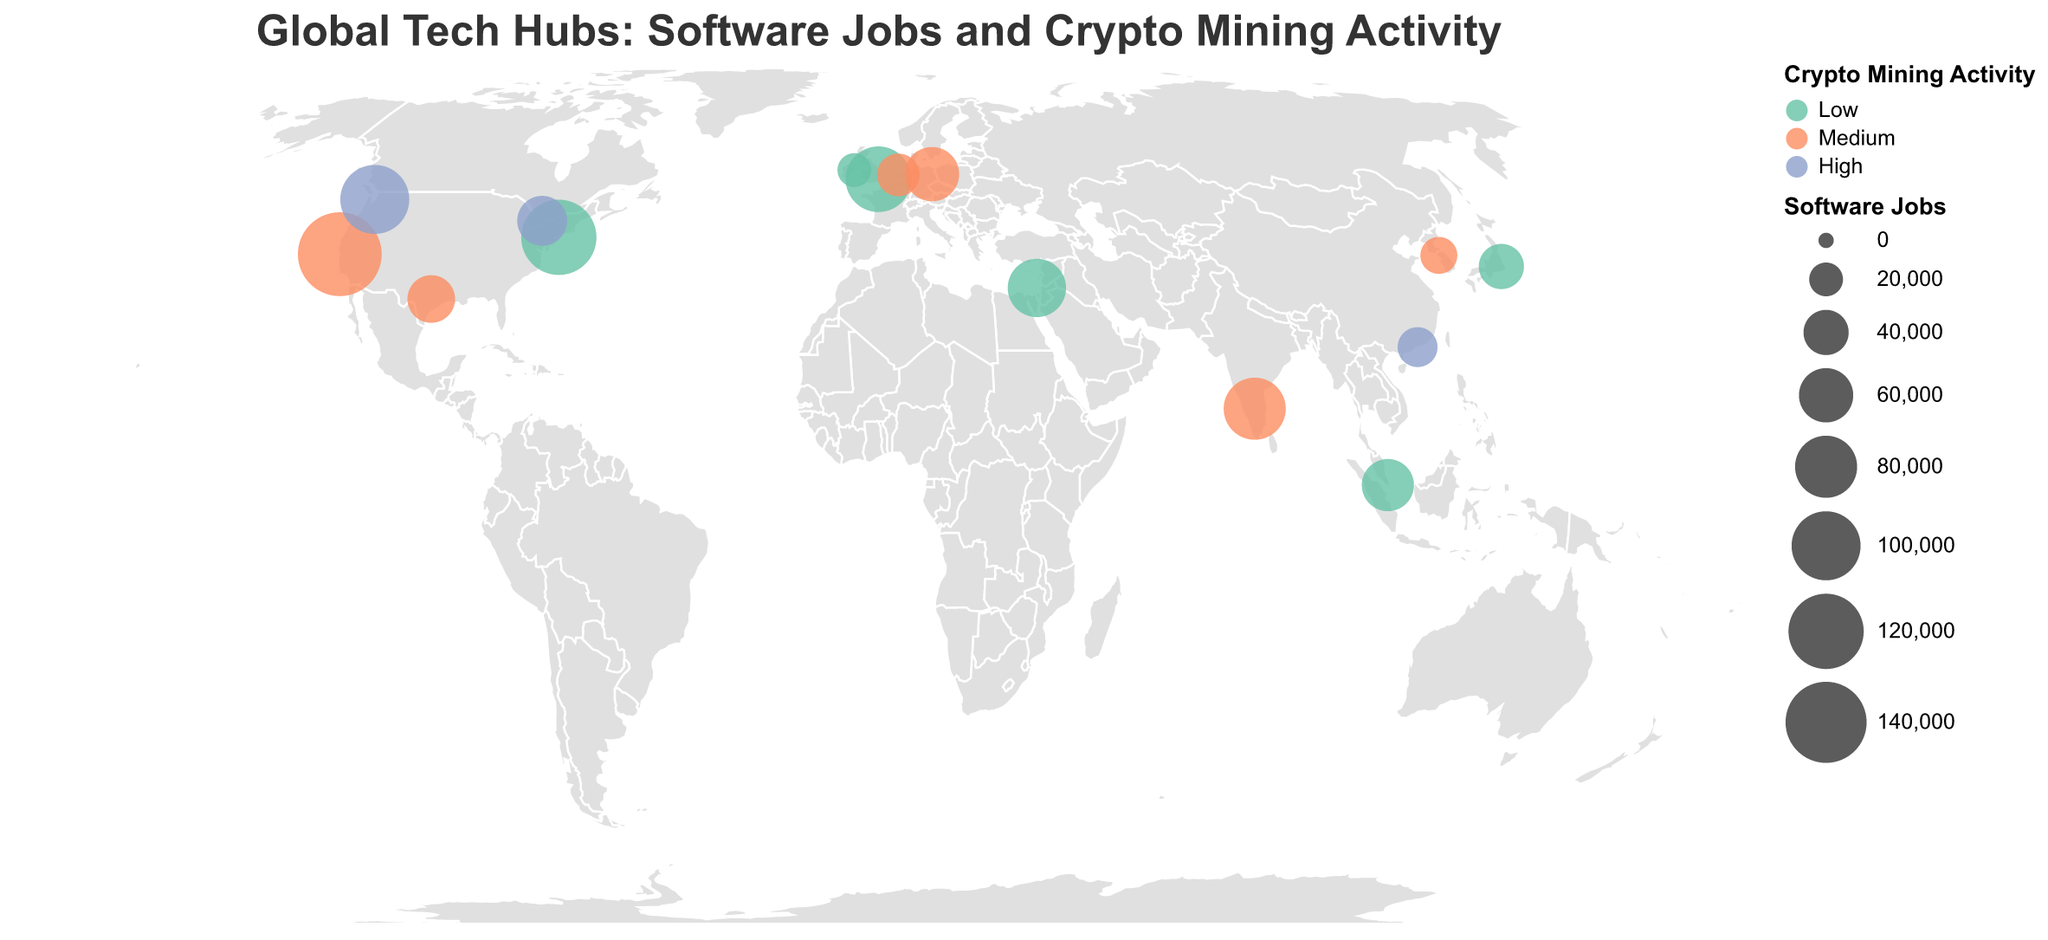Where is the highest-ranking tech hub located? By referring to the tooltip and the visual size and color of the circles, the highest-ranking tech hub is San Francisco in the USA, ranked number one.
Answer: San Francisco, USA Which city has the highest amount of software jobs? Looking at the sizes of the circles, the largest one represents the highest number of software jobs, which is in San Francisco with 150,000 jobs.
Answer: San Francisco What is the crypto mining activity level in Seattle? By hovering over Seattle and checking the tooltip or the color of the circle, we can see that Seattle has high crypto mining activity.
Answer: High How many tech hubs have medium crypto mining activity? By looking at the legend and counting the circles colored in the medium activity color, we find that five tech hubs have medium crypto mining activity.
Answer: 5 Which tech hub has more software jobs: Tel Aviv or Berlin? By comparing the sizes of the circles for Tel Aviv (70,000 jobs) and Berlin (60,000 jobs), Tel Aviv has more software jobs.
Answer: Tel Aviv Among the listed cities, which is the lowest-ranking tech hub, and where is it located? The lowest-ranking tech hub will be the one with the highest number in the tech hub rank. According to the data, Dublin, Ireland is ranked 15th.
Answer: Dublin, Ireland What is the total number of software jobs in American (USA) tech hubs from the data provided? We sum the software jobs from San Francisco (150,000), New York City (120,000), Seattle (100,000), and Austin (45,000). The total is 415,000.
Answer: 415,000 Which city in Asia has the lowest number of software jobs? By looking at the cities in Asia and their software jobs count in the figure, Tokyo has the lowest with 40,000 jobs.
Answer: Tokyo How many tech hubs are located in Europe? By identifying and counting the European cities from the tooltip, we find London, Berlin, Amsterdam, Dublin, making a total of four European tech hubs.
Answer: 4 Compare the crypto mining activity and software jobs of San Francisco and Shenzhen. San Francisco has a medium crypto mining activity level and 150,000 software jobs, while Shenzhen has high crypto mining activity and 30,000 software jobs.
Answer: San Francisco: medium, 150,000; Shenzhen: high, 30,000 